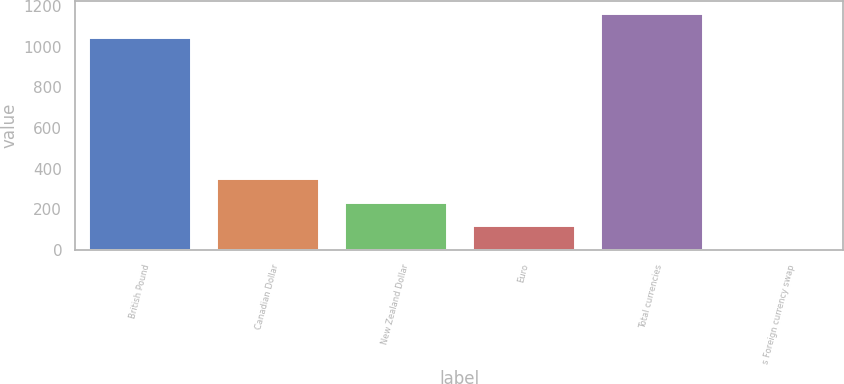Convert chart to OTSL. <chart><loc_0><loc_0><loc_500><loc_500><bar_chart><fcel>British Pound<fcel>Canadian Dollar<fcel>New Zealand Dollar<fcel>Euro<fcel>Total currencies<fcel>s Foreign currency swap<nl><fcel>1049<fcel>353.8<fcel>238.2<fcel>122.6<fcel>1164.6<fcel>7<nl></chart> 